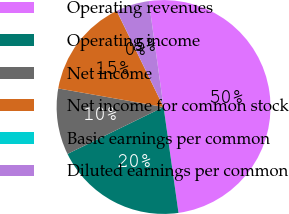Convert chart. <chart><loc_0><loc_0><loc_500><loc_500><pie_chart><fcel>Operating revenues<fcel>Operating income<fcel>Net income<fcel>Net income for common stock<fcel>Basic earnings per common<fcel>Diluted earnings per common<nl><fcel>49.97%<fcel>20.0%<fcel>10.01%<fcel>15.0%<fcel>0.01%<fcel>5.01%<nl></chart> 